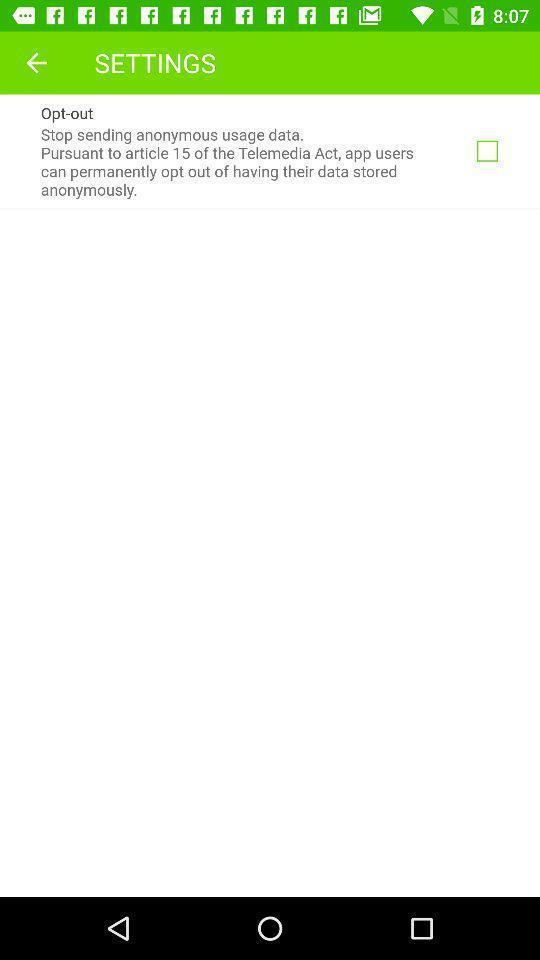Explain what's happening in this screen capture. Page shows the settings of usage data on social app. 